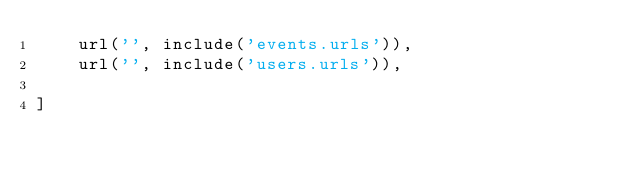<code> <loc_0><loc_0><loc_500><loc_500><_Python_>    url('', include('events.urls')),
    url('', include('users.urls')),

]
</code> 